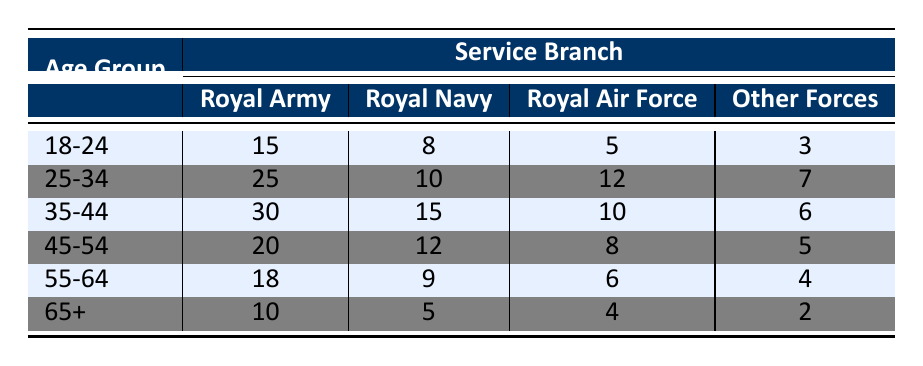What is the total number of veterans aged 18-24? To find the total for the age group 18-24, I look at the first row of the table and add the numbers from each service branch: 15 (Royal Army) + 8 (Royal Navy) + 5 (Royal Air Force) + 3 (Other Forces) = 31.
Answer: 31 Which service branch has the highest number of veterans in the 25-34 age group? From the second row, I see the counts: Royal Army has 25, Royal Navy has 10, Royal Air Force has 12, and Other Forces has 7. The highest count is 25 from the Royal Army.
Answer: Royal Army What is the average number of veterans across all service branches for the age group 45-54? In the 45-54 age group, the numbers are: Royal Army 20, Royal Navy 12, Royal Air Force 8, and Other Forces 5. Summing them gives 20 + 12 + 8 + 5 = 45. Dividing by the 4 service branches, the average is 45 / 4 = 11.25.
Answer: 11.25 Is there a higher number of veterans in the Royal Navy compared to Other Forces in the 65+ age group? In the 65+ age group, the Royal Navy has 5 veterans while Other Forces has 2. Since 5 is greater than 2, the statement is true.
Answer: Yes What is the total number of veterans across all age groups for the Royal Air Force? I need to sum the values in the Royal Air Force column for all age groups: 5 + 12 + 10 + 8 + 6 + 4 = 45.
Answer: 45 In which age group does the Royal Army have the least number of veterans? By examining the Royal Army column, the counts are: 15 (18-24), 25 (25-34), 30 (35-44), 20 (45-54), 18 (55-64), and 10 (65+). The least is 10, which corresponds to the 65+ age group.
Answer: 65+ How many more veterans are there in the 35-44 age group compared to the 55-64 age group across all branches combined? First, sum the veterans in the 35-44 age group: 30 + 15 + 10 + 6 = 61. Then for the 55-64 age group: 18 + 9 + 6 + 4 = 37. The difference is 61 - 37 = 24.
Answer: 24 Which age group has the highest number of veterans when combined across all branches? Summing each age group's total: 18-24 = 31, 25-34 = 54, 35-44 = 61, 45-54 = 45, 55-64 = 37, and 65+ = 21. The highest is 61 for the 35-44 age group.
Answer: 35-44 Is it true that the number of Royal Army veterans in the age group 55-64 is greater than the veterans from Other Forces in the same age group? The Royal Army has 18 veterans and Other Forces has 4. Since 18 is greater than 4, the statement is true.
Answer: Yes What percentage of the total number of veterans in the age group 25-34 served in the Royal Navy? The total in the 25-34 age group is 25 + 10 + 12 + 7 = 54. The number serving in the Royal Navy is 10. To find the percentage, (10 / 54) * 100 = 18.52%.
Answer: 18.52% 